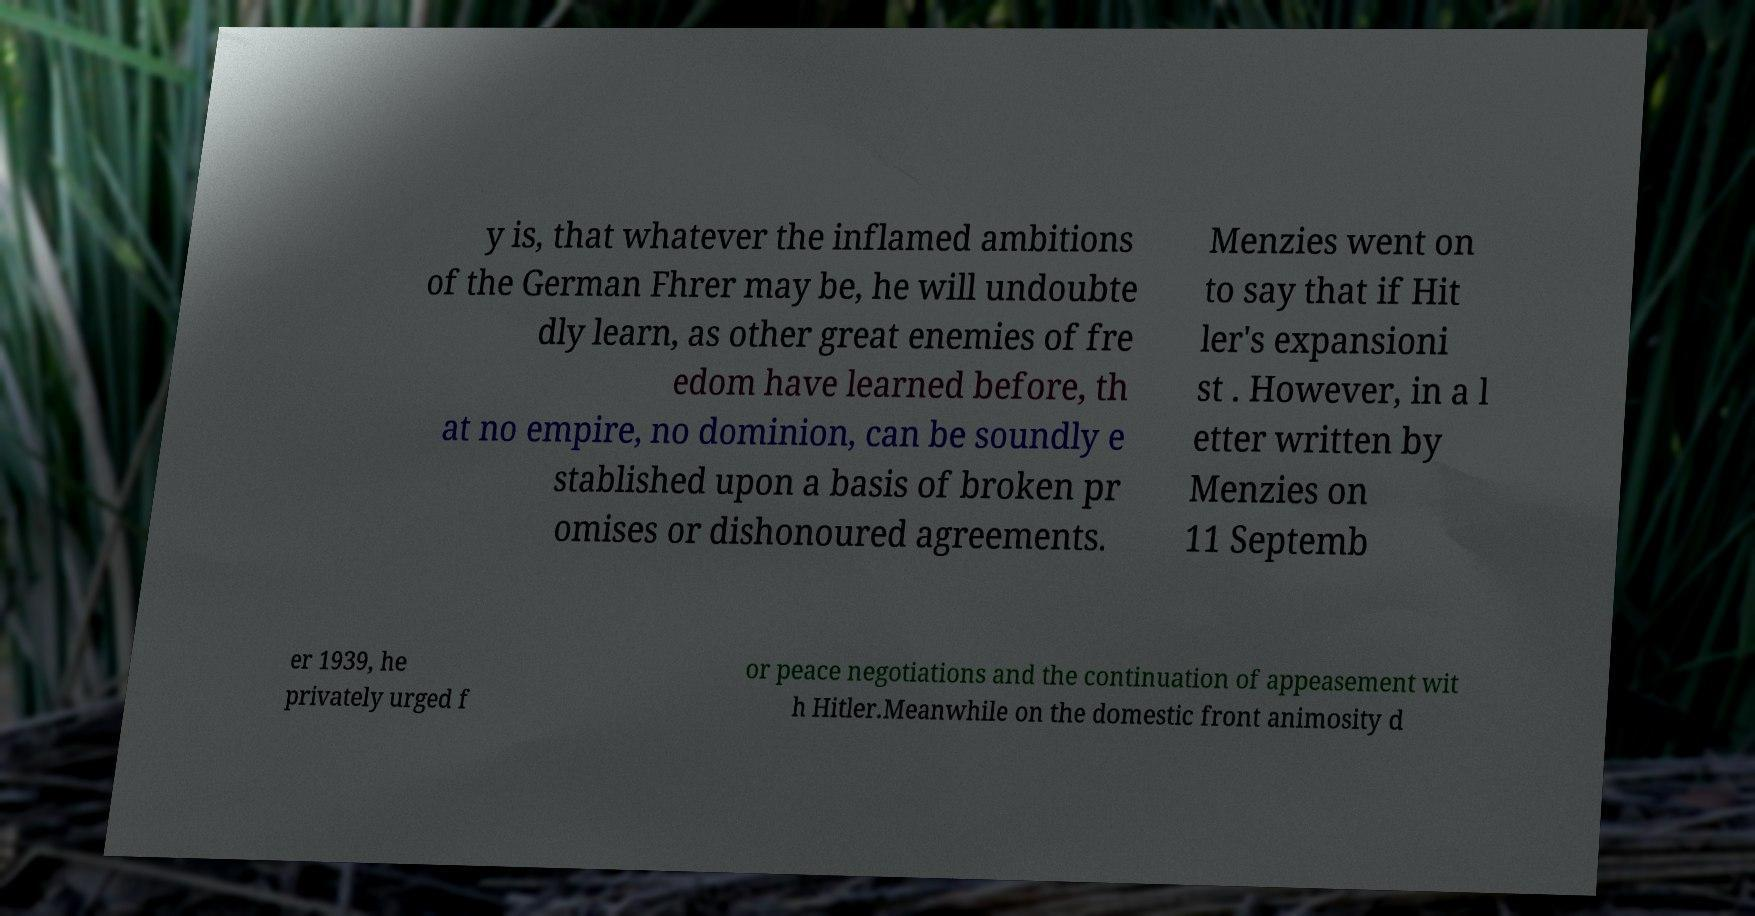Could you assist in decoding the text presented in this image and type it out clearly? y is, that whatever the inflamed ambitions of the German Fhrer may be, he will undoubte dly learn, as other great enemies of fre edom have learned before, th at no empire, no dominion, can be soundly e stablished upon a basis of broken pr omises or dishonoured agreements. Menzies went on to say that if Hit ler's expansioni st . However, in a l etter written by Menzies on 11 Septemb er 1939, he privately urged f or peace negotiations and the continuation of appeasement wit h Hitler.Meanwhile on the domestic front animosity d 